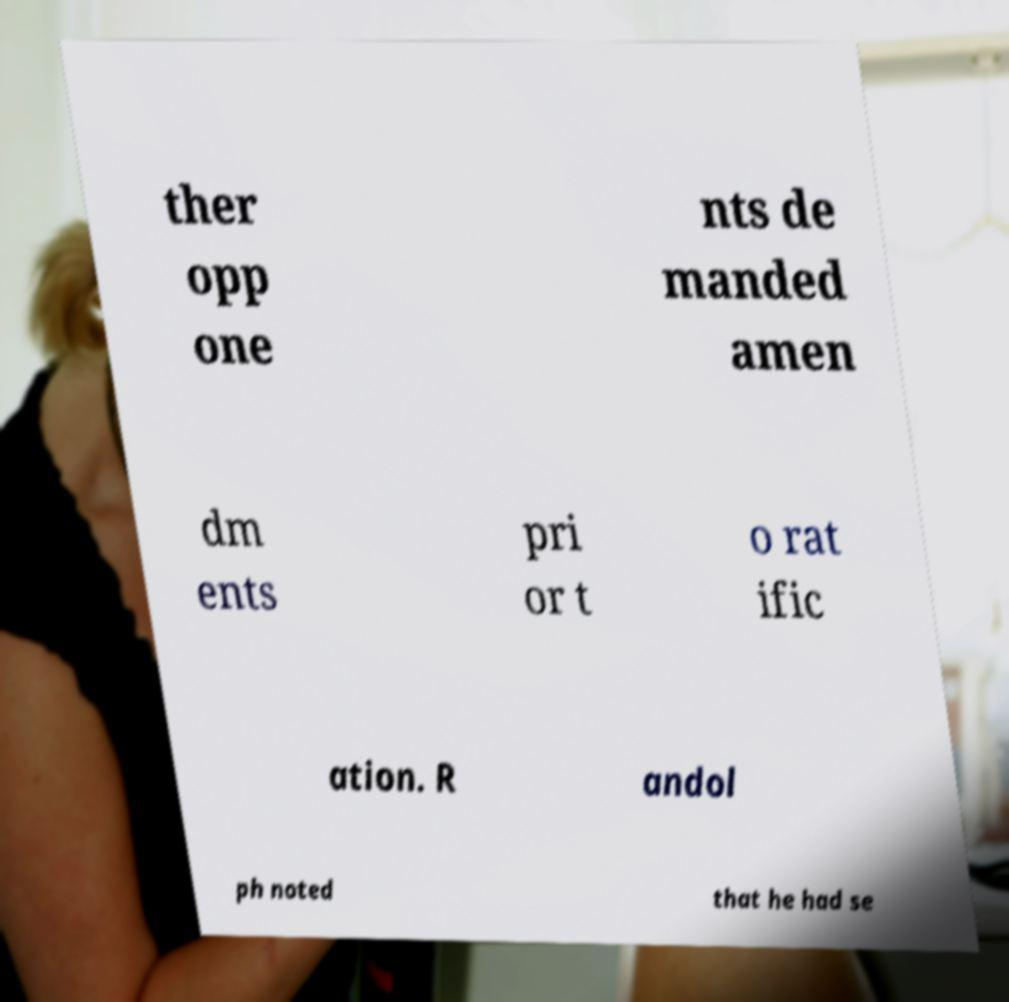What messages or text are displayed in this image? I need them in a readable, typed format. ther opp one nts de manded amen dm ents pri or t o rat ific ation. R andol ph noted that he had se 